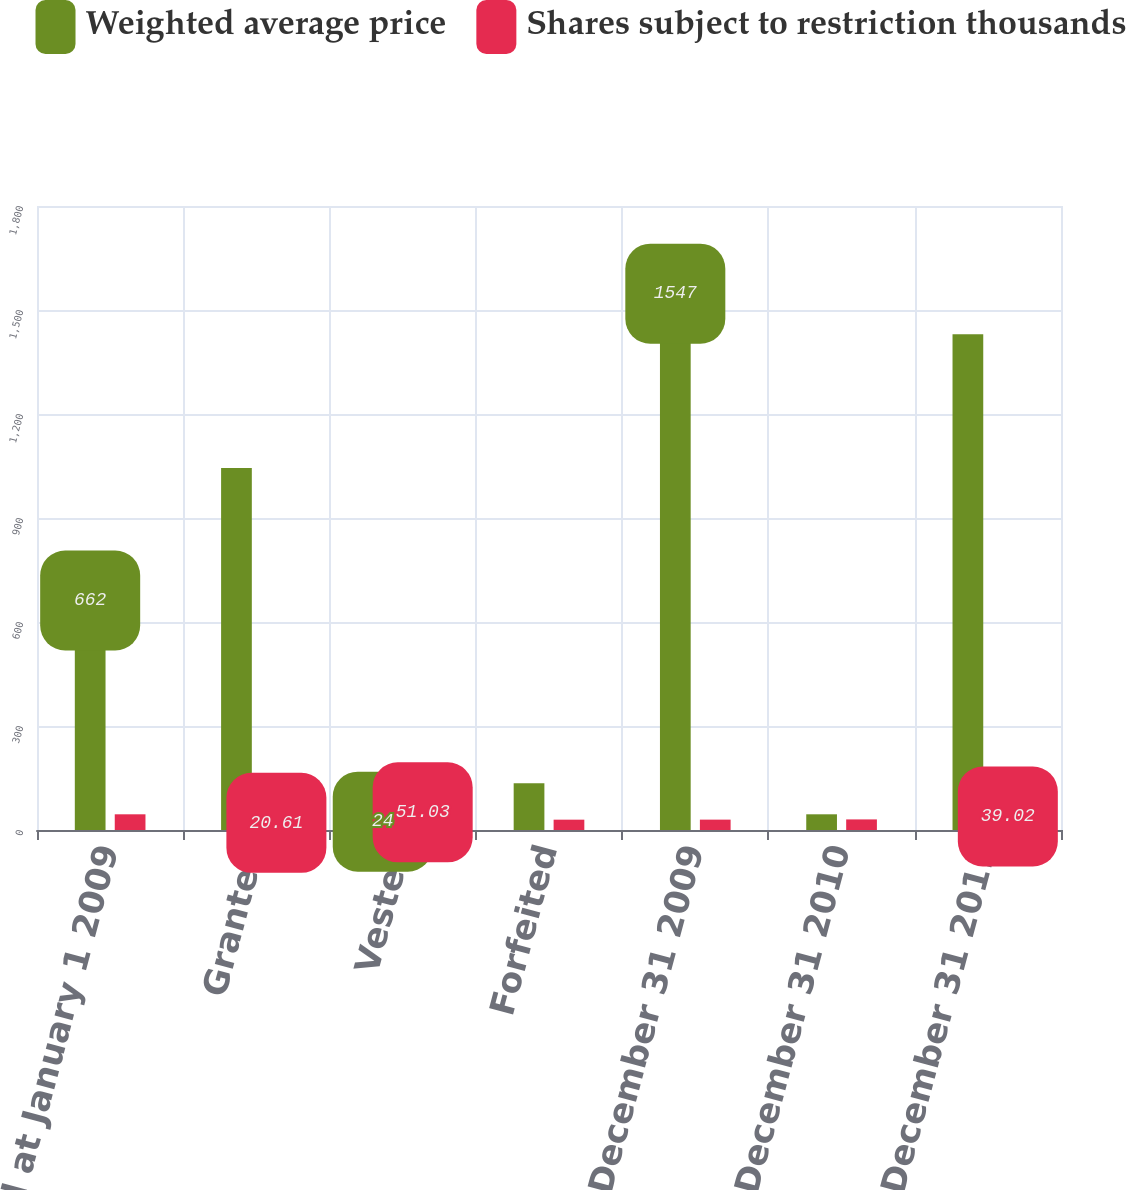<chart> <loc_0><loc_0><loc_500><loc_500><stacked_bar_chart><ecel><fcel>Nonvested at January 1 2009<fcel>Granted<fcel>Vested<fcel>Forfeited<fcel>Nonvested at December 31 2009<fcel>Nonvested at December 31 2010<fcel>Nonvested at December 31 2011<nl><fcel>Weighted average price<fcel>662<fcel>1044<fcel>24<fcel>135<fcel>1547<fcel>45.29<fcel>1430<nl><fcel>Shares subject to restriction thousands<fcel>45.29<fcel>20.61<fcel>51.03<fcel>29.79<fcel>29.9<fcel>30.55<fcel>39.02<nl></chart> 